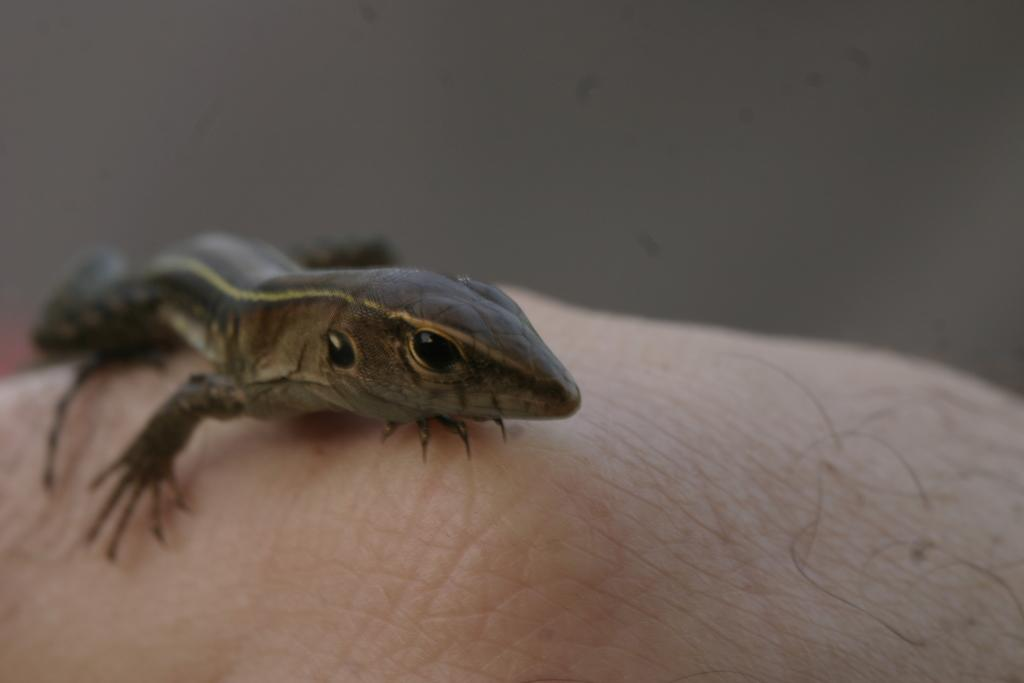What is the main subject of the image? There is a lizard in the center of the image. What type of silk apparel is the lizard wearing in the image? There is no silk apparel present in the image, as it features a lizard without any clothing. 